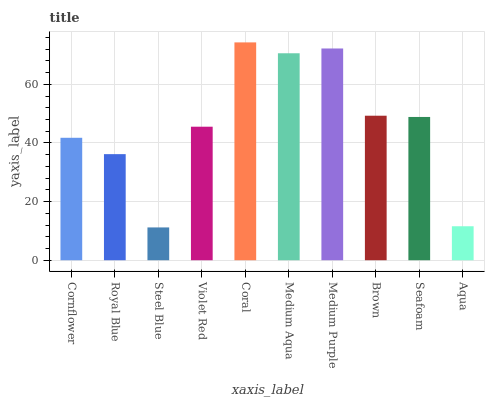Is Steel Blue the minimum?
Answer yes or no. Yes. Is Coral the maximum?
Answer yes or no. Yes. Is Royal Blue the minimum?
Answer yes or no. No. Is Royal Blue the maximum?
Answer yes or no. No. Is Cornflower greater than Royal Blue?
Answer yes or no. Yes. Is Royal Blue less than Cornflower?
Answer yes or no. Yes. Is Royal Blue greater than Cornflower?
Answer yes or no. No. Is Cornflower less than Royal Blue?
Answer yes or no. No. Is Seafoam the high median?
Answer yes or no. Yes. Is Violet Red the low median?
Answer yes or no. Yes. Is Coral the high median?
Answer yes or no. No. Is Aqua the low median?
Answer yes or no. No. 